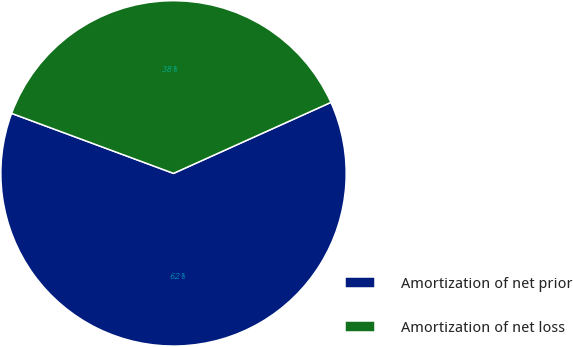Convert chart to OTSL. <chart><loc_0><loc_0><loc_500><loc_500><pie_chart><fcel>Amortization of net prior<fcel>Amortization of net loss<nl><fcel>62.39%<fcel>37.61%<nl></chart> 